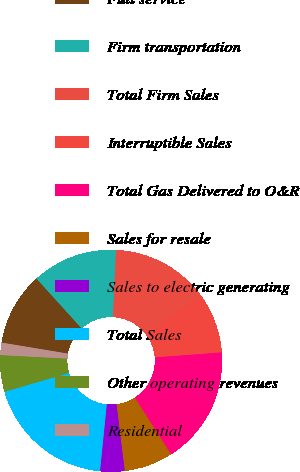<chart> <loc_0><loc_0><loc_500><loc_500><pie_chart><fcel>Full service<fcel>Firm transportation<fcel>Total Firm Sales<fcel>Interruptible Sales<fcel>Total Gas Delivered to O&R<fcel>Sales for resale<fcel>Sales to electric generating<fcel>Total Sales<fcel>Other operating revenues<fcel>Residential<nl><fcel>10.66%<fcel>12.43%<fcel>14.21%<fcel>8.88%<fcel>17.14%<fcel>7.11%<fcel>3.56%<fcel>18.91%<fcel>5.33%<fcel>1.78%<nl></chart> 